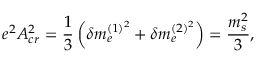<formula> <loc_0><loc_0><loc_500><loc_500>e ^ { 2 } A _ { c r } ^ { 2 } = { \frac { 1 } { 3 } } \left ( \delta m _ { e } ^ { ( 1 ) ^ { 2 } } + \delta m _ { e } ^ { ( 2 ) ^ { 2 } } \right ) = { \frac { m _ { s } ^ { 2 } } { 3 } } ,</formula> 